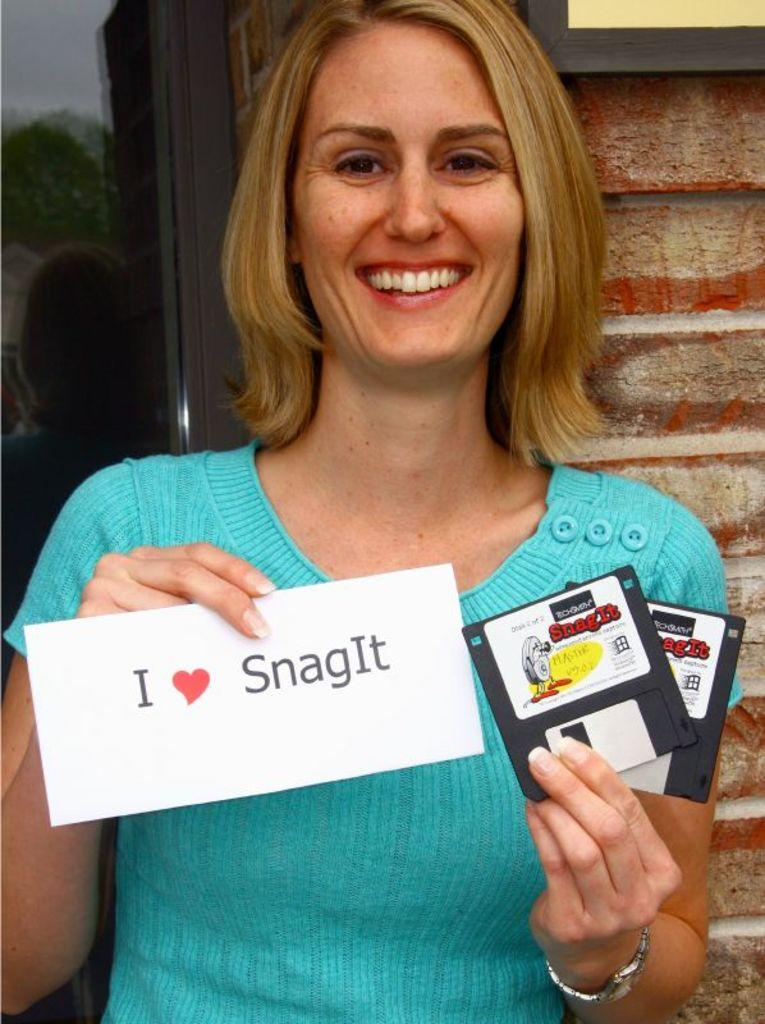Who is the main subject in the image? There is a woman in the image. What is the woman holding in her hands? The woman is holding cards in her hands. What is the woman's posture in the image? The woman is standing. What is the woman's facial expression in the image? The woman is smiling. What can be seen in the background of the image? There is a frame on the wall in the background of the image. What type of straw is the woman using to spy on her neighbor in the image? There is no straw or spying activity present in the image. The woman is simply holding cards and smiling. 